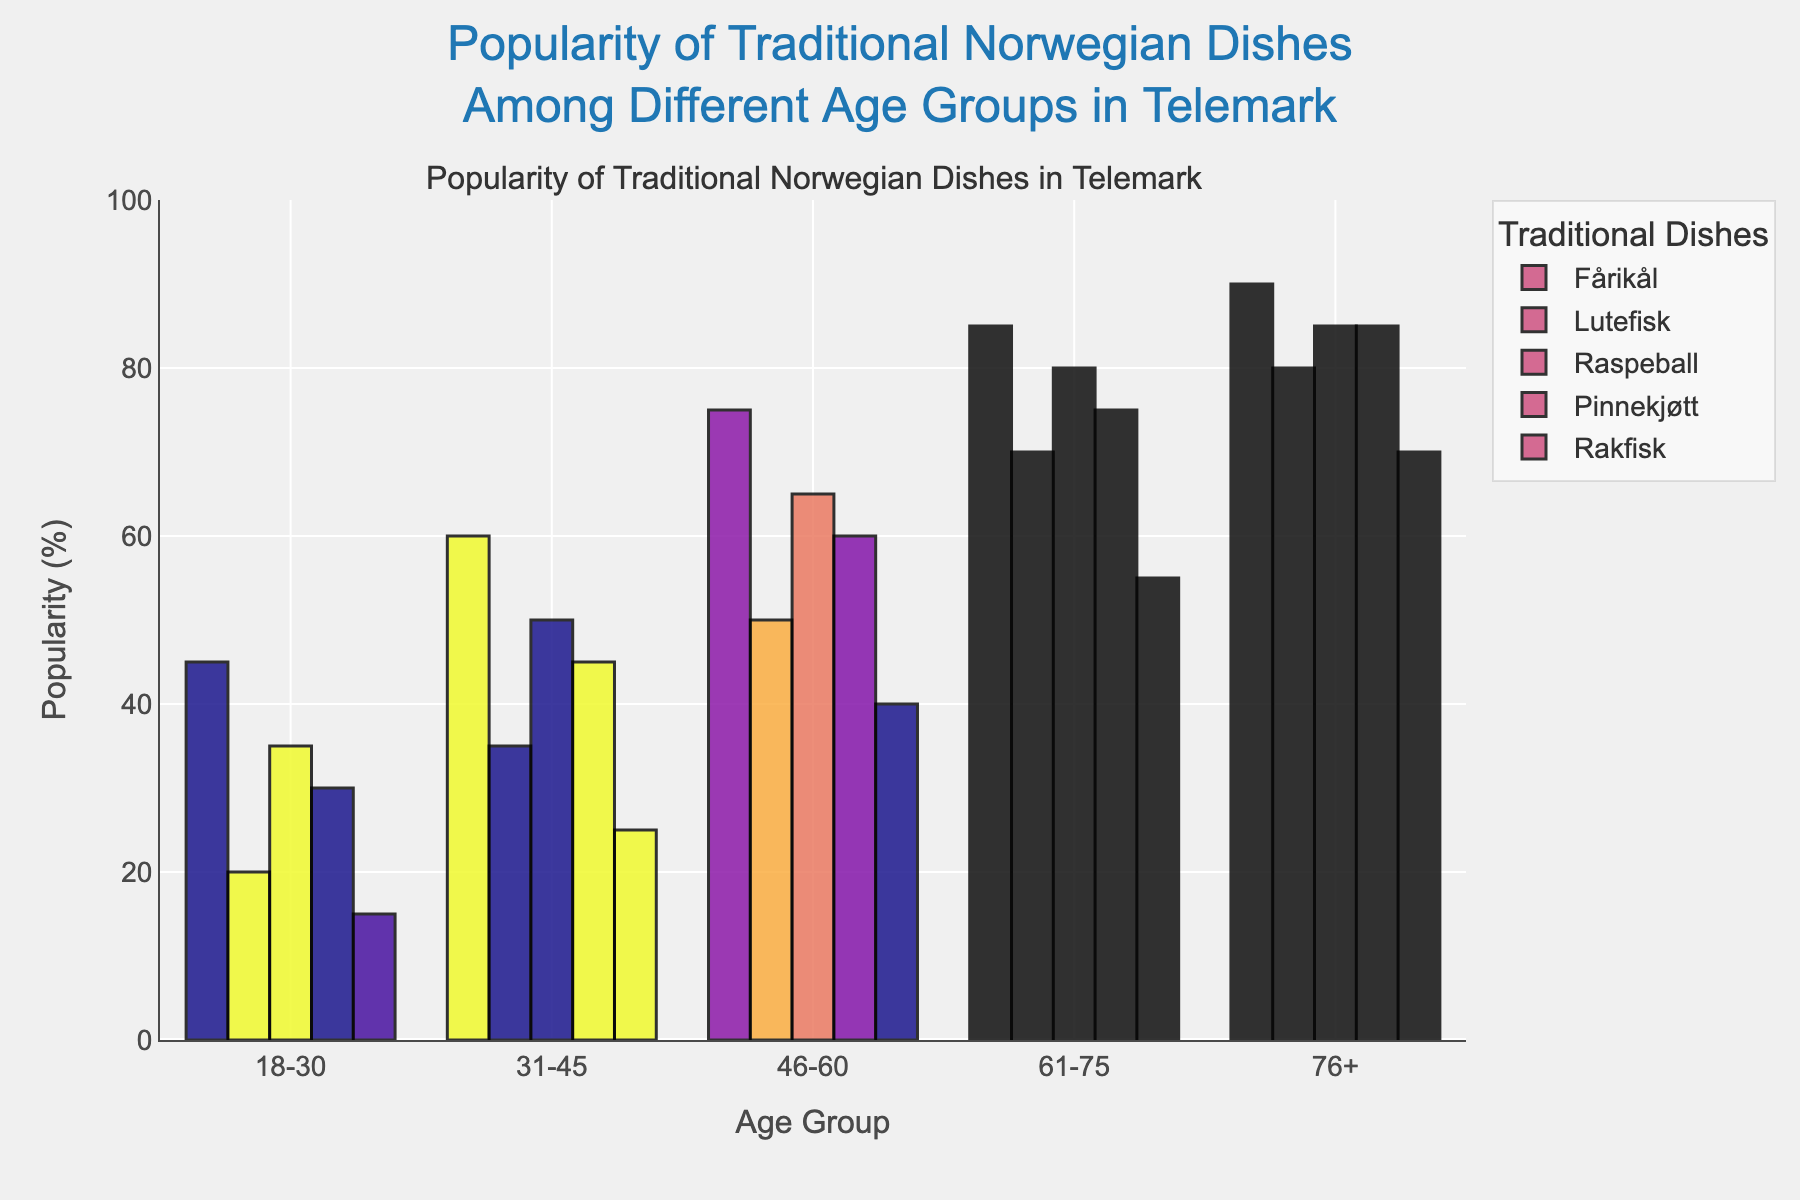Which age group has the highest preference for Lutefisk? By examining the bars corresponding to Lutefisk across all age groups, the highest bar belongs to the 76+ age group.
Answer: 76+ Which dish is most popular among the 61-75 age group? Look for the tallest bar in the 61-75 age group column. The tallest bar corresponds to Fårikål.
Answer: Fårikål What is the difference in popularity between Fårikål and Rakfisk in the 31-45 age group? The bar height for Fårikål in the 31-45 age group is 60, and for Rakfisk, it is 25. The difference is 60 - 25.
Answer: 35 Which age group shows the smallest interest in Raspeball? Locate the shortest bar for Raspeball across all age groups, which corresponds to the 18-30 age group.
Answer: 18-30 What is the average popularity of Pinnekjøtt across all age groups? Sum the popularity rates of Pinnekjøtt for all age groups (30 + 45 + 60 + 75 + 85) and divide by the number of age groups (5). The calculation is (30 + 45 + 60 + 75 + 85) / 5 = 59.
Answer: 59 Is the popularity of Rakfisk higher in the 46-60 age group compared to the 61-75 age group? Compare the bar heights for Rakfisk between the 46-60 and 61-75 age groups. The height for 46-60 is 40, and for 61-75, it is 55. Since 40 < 55, the popularity is not higher in the 46-60 age group.
Answer: No Rank the dishes by their popularity among the 76+ age group. By examining the bar heights of the 76+ age group for each dish, the order from highest to lowest is as follows: Fårikål (90), Pinnekjøtt (85), Raspeball (85), Lutefisk (80), Rakfisk (70).
Answer: Fårikål, Pinnekjøtt, Raspeball, Lutefisk, Rakfisk What is the combined popularity of Lutefisk and Raspeball in the 18-30 age group? Sum the values for Lutefisk (20) and Raspeball (35) in the 18-30 age group. The calculation is 20 + 35 = 55.
Answer: 55 Which dish has the most consistent popularity across all age groups? Determine the variation in the bar heights for each dish across all age groups. Fårikål has the smallest variation and the most consistent popularity overall.
Answer: Fårikål How does the popularity of Pinnekjøtt among the 18-30 age group compare to the 76+ age group? The bar height for Pinnekjøtt in the 18-30 age group is 30, and in the 76+ age group, the height is 85. The popularity is significantly higher in the 76+ age group compared to the 18-30 age group.
Answer: Lower in 18-30 